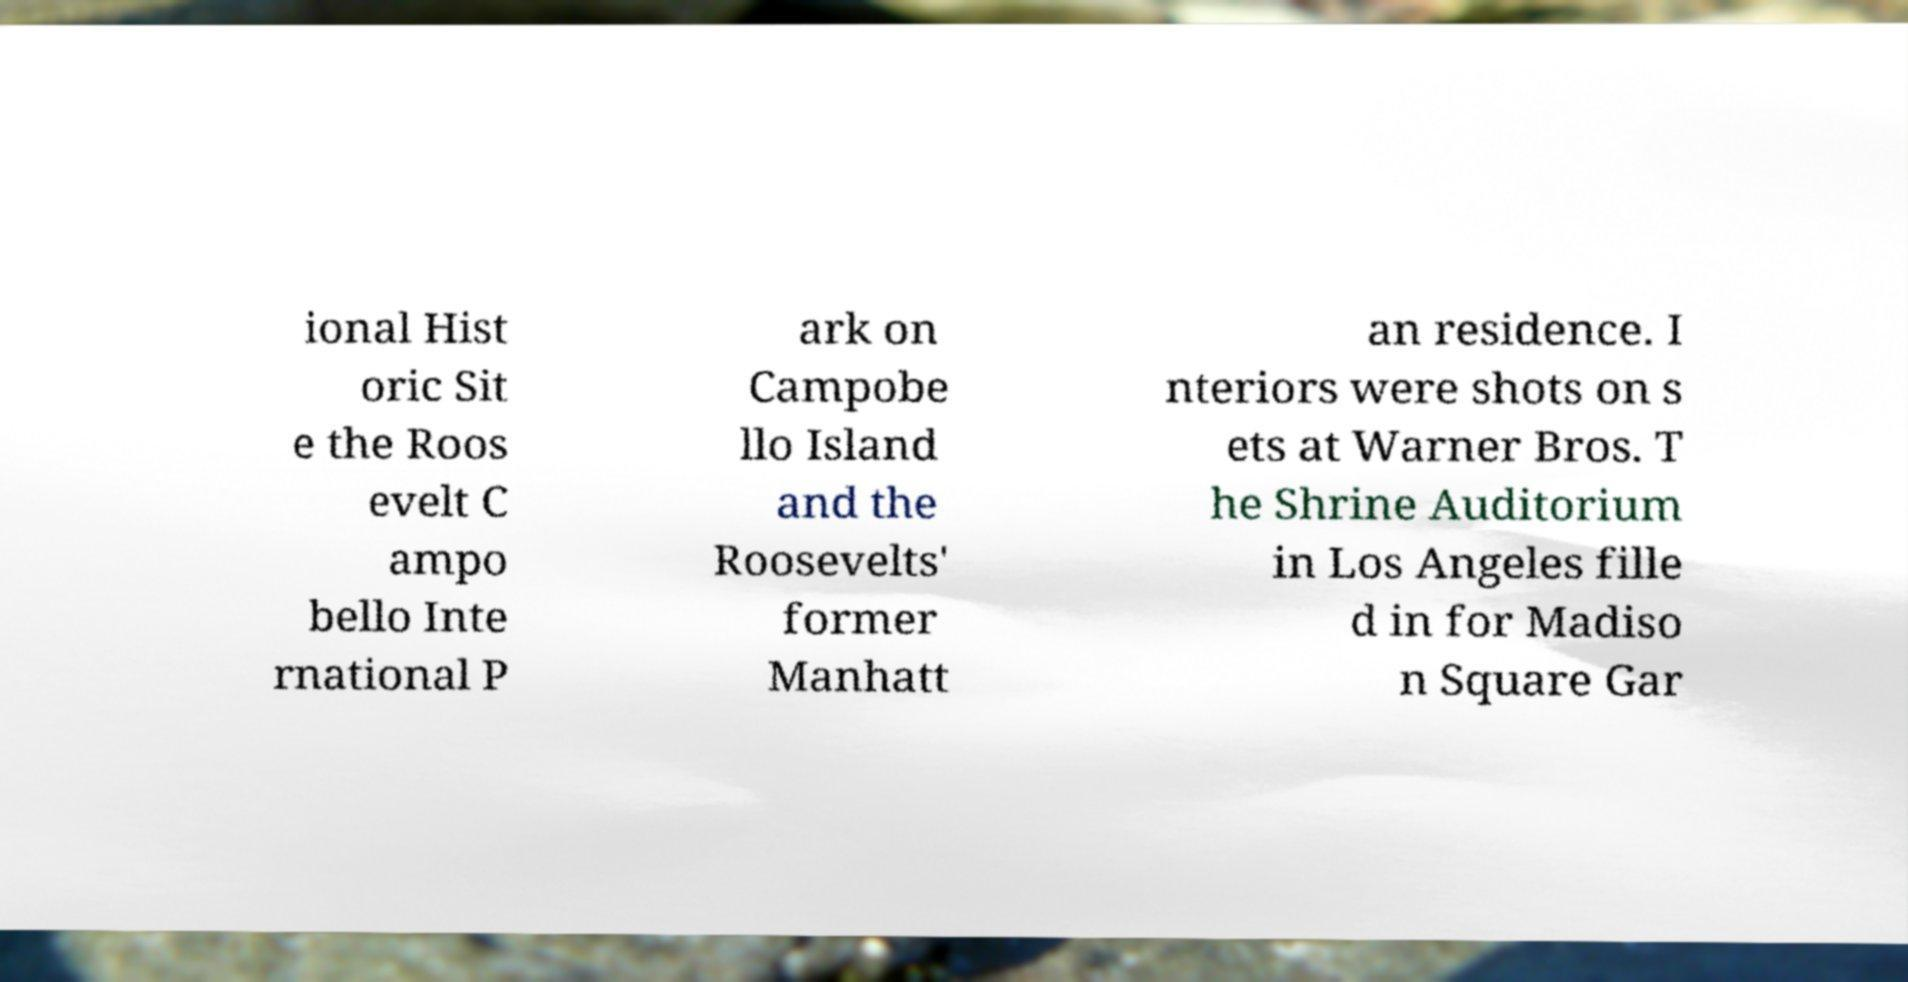There's text embedded in this image that I need extracted. Can you transcribe it verbatim? ional Hist oric Sit e the Roos evelt C ampo bello Inte rnational P ark on Campobe llo Island and the Roosevelts' former Manhatt an residence. I nteriors were shots on s ets at Warner Bros. T he Shrine Auditorium in Los Angeles fille d in for Madiso n Square Gar 